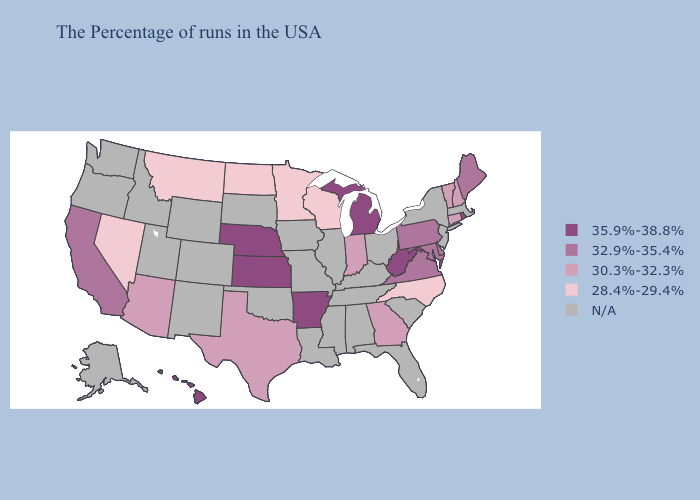Does the map have missing data?
Concise answer only. Yes. What is the highest value in states that border Wisconsin?
Be succinct. 35.9%-38.8%. What is the lowest value in the Northeast?
Be succinct. 30.3%-32.3%. What is the lowest value in states that border Georgia?
Concise answer only. 28.4%-29.4%. Which states have the lowest value in the USA?
Keep it brief. North Carolina, Wisconsin, Minnesota, North Dakota, Montana, Nevada. Is the legend a continuous bar?
Keep it brief. No. Does Hawaii have the highest value in the USA?
Answer briefly. Yes. Name the states that have a value in the range 32.9%-35.4%?
Be succinct. Maine, Delaware, Maryland, Pennsylvania, Virginia, California. How many symbols are there in the legend?
Keep it brief. 5. Does Kansas have the highest value in the MidWest?
Be succinct. Yes. Name the states that have a value in the range 32.9%-35.4%?
Answer briefly. Maine, Delaware, Maryland, Pennsylvania, Virginia, California. Name the states that have a value in the range 28.4%-29.4%?
Quick response, please. North Carolina, Wisconsin, Minnesota, North Dakota, Montana, Nevada. What is the lowest value in the USA?
Concise answer only. 28.4%-29.4%. Among the states that border Utah , which have the lowest value?
Write a very short answer. Nevada. 